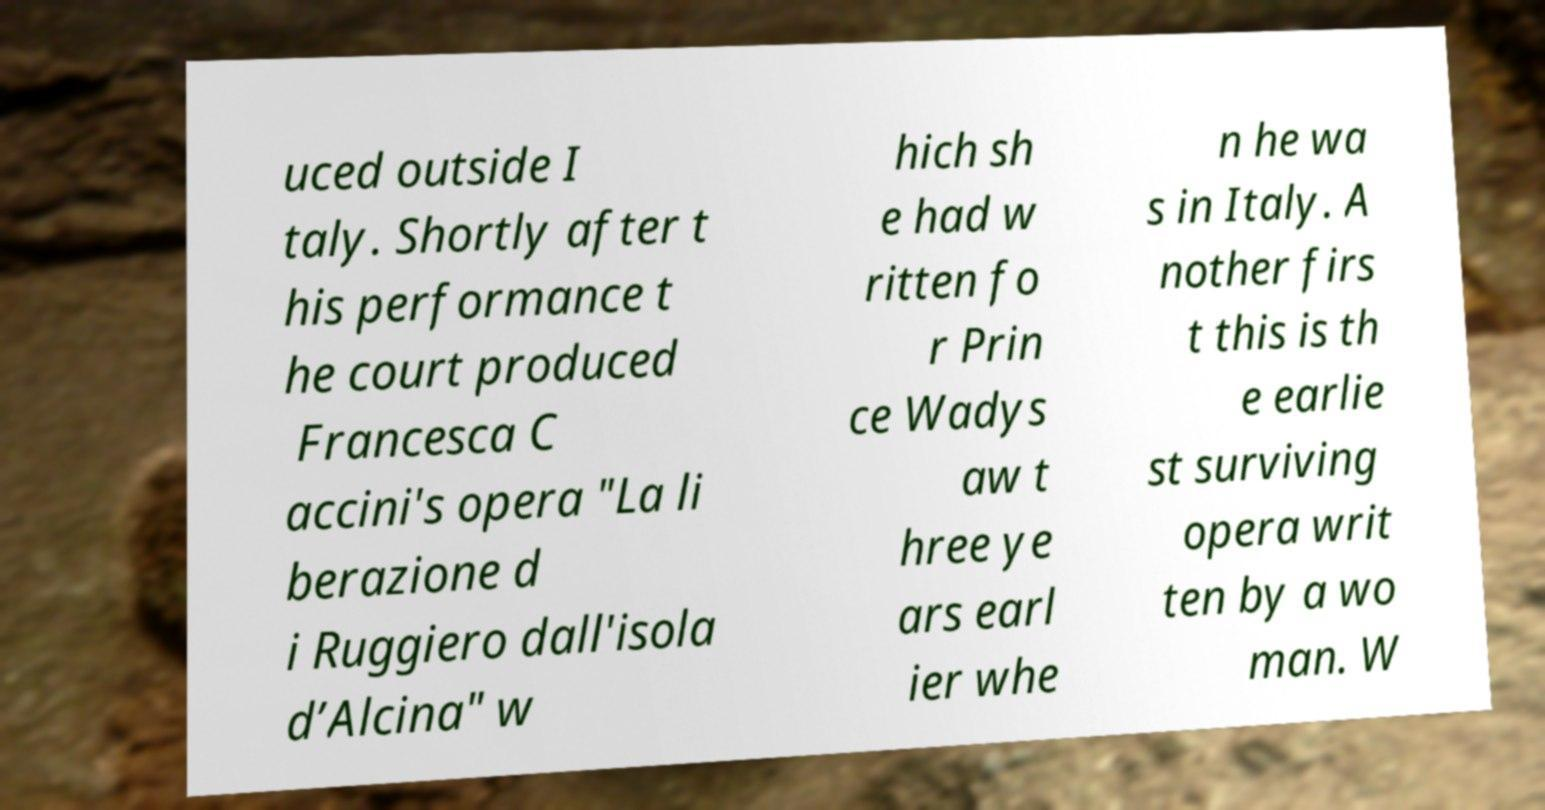Could you assist in decoding the text presented in this image and type it out clearly? uced outside I taly. Shortly after t his performance t he court produced Francesca C accini's opera "La li berazione d i Ruggiero dall'isola d’Alcina" w hich sh e had w ritten fo r Prin ce Wadys aw t hree ye ars earl ier whe n he wa s in Italy. A nother firs t this is th e earlie st surviving opera writ ten by a wo man. W 